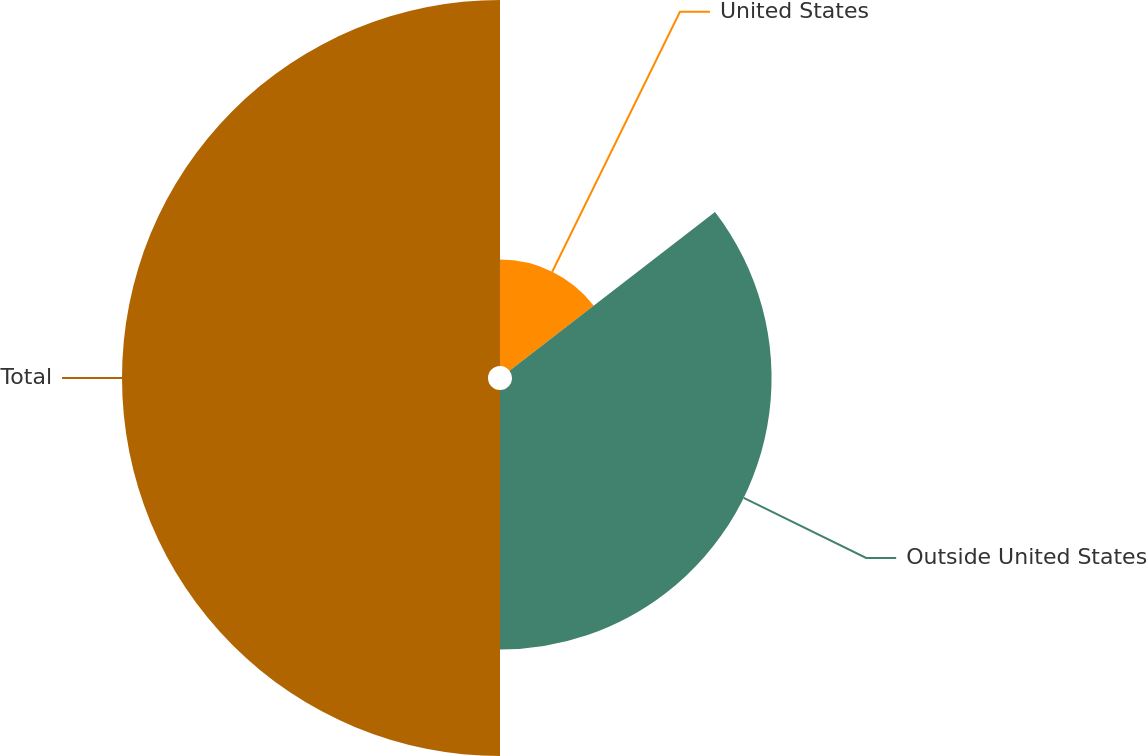Convert chart to OTSL. <chart><loc_0><loc_0><loc_500><loc_500><pie_chart><fcel>United States<fcel>Outside United States<fcel>Total<nl><fcel>14.54%<fcel>35.46%<fcel>50.0%<nl></chart> 